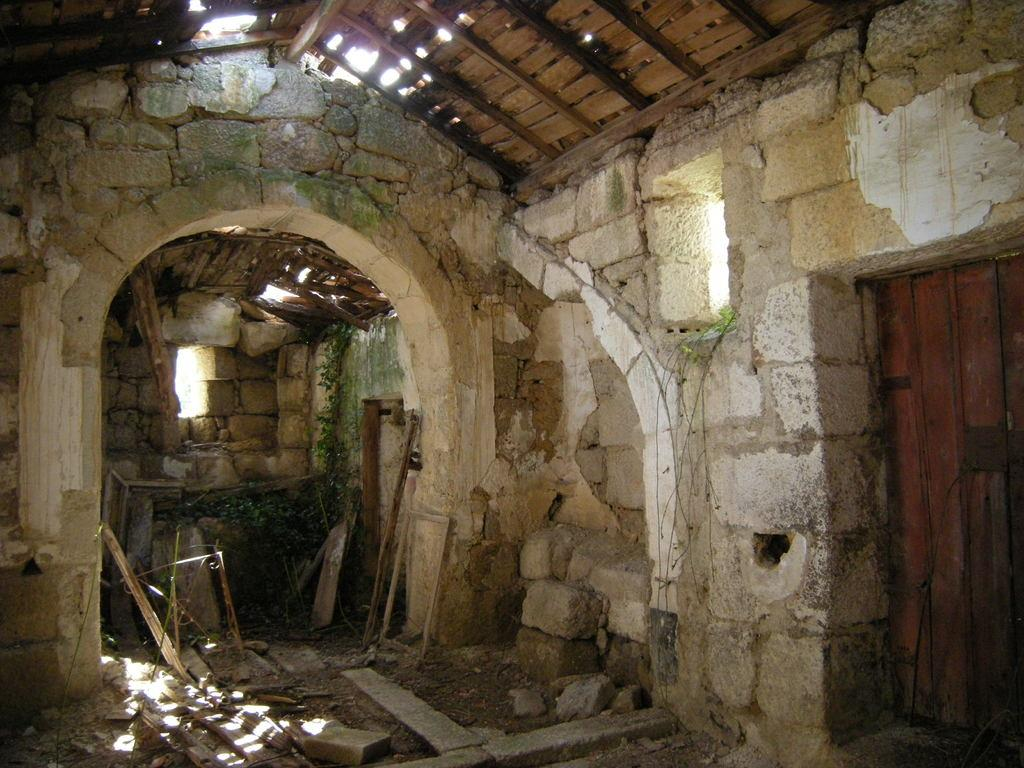What type of wall is visible in the image? There is a brick wall in the image. What is above the brick wall in the image? There is a wooden roof above the brick wall in the image. How many partners are involved in the society depicted in the image? There is no depiction of a society or partners in the image; it only features a brick wall and a wooden roof. 